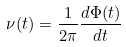Convert formula to latex. <formula><loc_0><loc_0><loc_500><loc_500>\nu ( t ) = \frac { 1 } { 2 \pi } \frac { d \Phi ( t ) } { d t }</formula> 